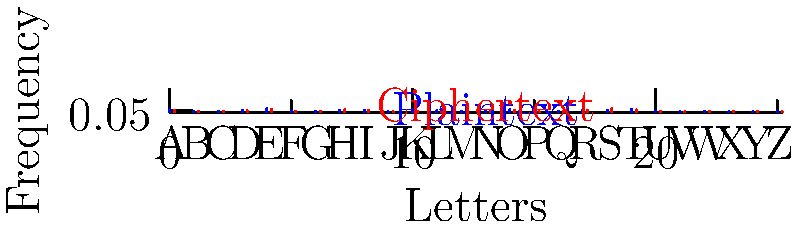Given the frequency distribution graphs for plaintext (blue) and ciphertext (red), what type of encryption method was likely used, and what is a potential weakness of this method that could be exploited for decryption without joining any cryptography groups or mailing lists? To answer this question, we need to analyze the frequency distribution graphs and consider common encryption methods:

1. Observe that the frequency distribution of the ciphertext (red) appears to be a shifted version of the plaintext distribution (blue).

2. This shift in frequency distribution is characteristic of a simple substitution cipher, specifically a Caesar cipher or a shift cipher.

3. In a Caesar cipher, each letter in the plaintext is shifted by a fixed number of positions in the alphabet. For example, with a shift of 3, 'A' becomes 'D', 'B' becomes 'E', and so on.

4. The weakness of this method lies in its preservation of the frequency distribution pattern. The most frequent letter in English ('E') will still be the most frequent letter in the ciphertext, just shifted.

5. To exploit this weakness for decryption:
   a. Identify the most frequent letter in the ciphertext (appears to be 'S' from the graph).
   b. Assume this corresponds to 'E' in the plaintext.
   c. Calculate the shift: 'S' is 18 positions after 'E' in the alphabet.
   d. Apply this shift to all other letters to attempt decryption.

6. This method can be performed individually without joining any groups or mailing lists, aligning with the persona's preference for privacy.

7. The effectiveness of this approach is due to the cipher's inability to mask the underlying frequency distribution of the language.
Answer: Caesar cipher; frequency analysis 